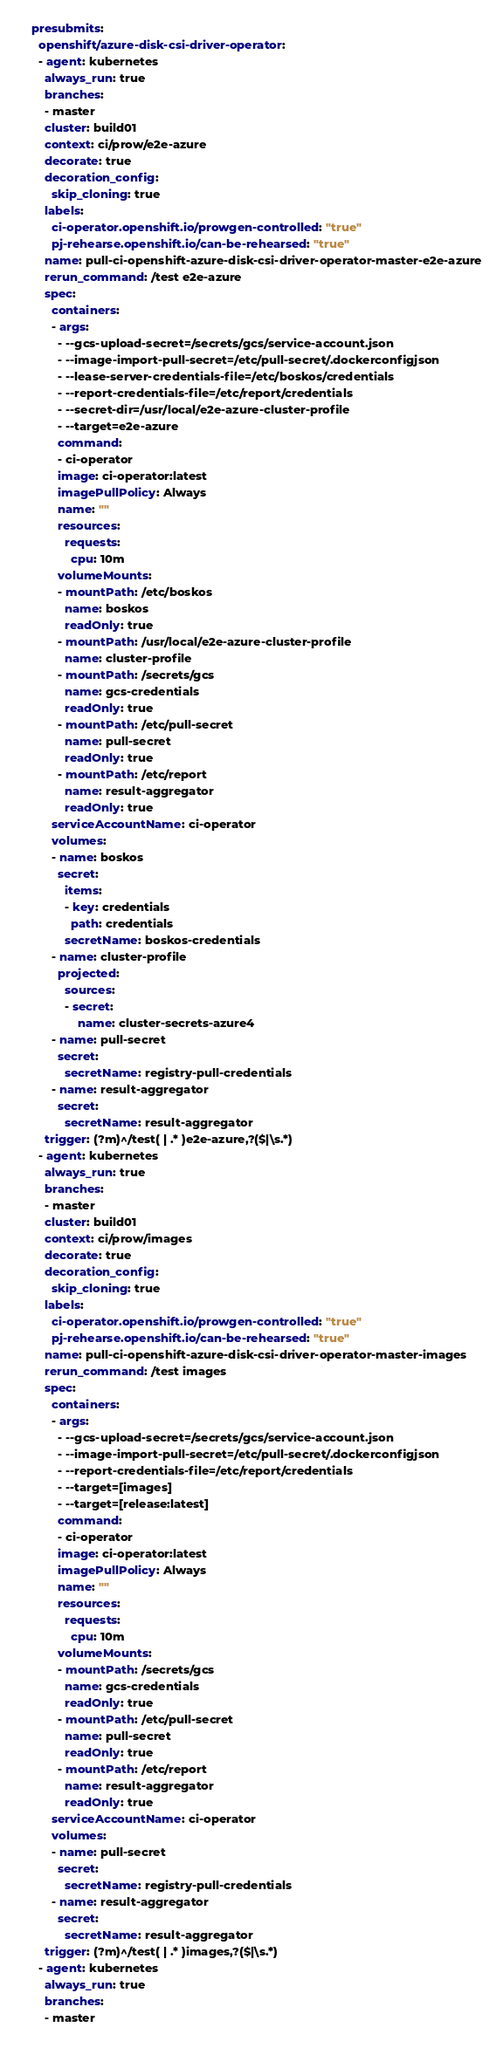<code> <loc_0><loc_0><loc_500><loc_500><_YAML_>presubmits:
  openshift/azure-disk-csi-driver-operator:
  - agent: kubernetes
    always_run: true
    branches:
    - master
    cluster: build01
    context: ci/prow/e2e-azure
    decorate: true
    decoration_config:
      skip_cloning: true
    labels:
      ci-operator.openshift.io/prowgen-controlled: "true"
      pj-rehearse.openshift.io/can-be-rehearsed: "true"
    name: pull-ci-openshift-azure-disk-csi-driver-operator-master-e2e-azure
    rerun_command: /test e2e-azure
    spec:
      containers:
      - args:
        - --gcs-upload-secret=/secrets/gcs/service-account.json
        - --image-import-pull-secret=/etc/pull-secret/.dockerconfigjson
        - --lease-server-credentials-file=/etc/boskos/credentials
        - --report-credentials-file=/etc/report/credentials
        - --secret-dir=/usr/local/e2e-azure-cluster-profile
        - --target=e2e-azure
        command:
        - ci-operator
        image: ci-operator:latest
        imagePullPolicy: Always
        name: ""
        resources:
          requests:
            cpu: 10m
        volumeMounts:
        - mountPath: /etc/boskos
          name: boskos
          readOnly: true
        - mountPath: /usr/local/e2e-azure-cluster-profile
          name: cluster-profile
        - mountPath: /secrets/gcs
          name: gcs-credentials
          readOnly: true
        - mountPath: /etc/pull-secret
          name: pull-secret
          readOnly: true
        - mountPath: /etc/report
          name: result-aggregator
          readOnly: true
      serviceAccountName: ci-operator
      volumes:
      - name: boskos
        secret:
          items:
          - key: credentials
            path: credentials
          secretName: boskos-credentials
      - name: cluster-profile
        projected:
          sources:
          - secret:
              name: cluster-secrets-azure4
      - name: pull-secret
        secret:
          secretName: registry-pull-credentials
      - name: result-aggregator
        secret:
          secretName: result-aggregator
    trigger: (?m)^/test( | .* )e2e-azure,?($|\s.*)
  - agent: kubernetes
    always_run: true
    branches:
    - master
    cluster: build01
    context: ci/prow/images
    decorate: true
    decoration_config:
      skip_cloning: true
    labels:
      ci-operator.openshift.io/prowgen-controlled: "true"
      pj-rehearse.openshift.io/can-be-rehearsed: "true"
    name: pull-ci-openshift-azure-disk-csi-driver-operator-master-images
    rerun_command: /test images
    spec:
      containers:
      - args:
        - --gcs-upload-secret=/secrets/gcs/service-account.json
        - --image-import-pull-secret=/etc/pull-secret/.dockerconfigjson
        - --report-credentials-file=/etc/report/credentials
        - --target=[images]
        - --target=[release:latest]
        command:
        - ci-operator
        image: ci-operator:latest
        imagePullPolicy: Always
        name: ""
        resources:
          requests:
            cpu: 10m
        volumeMounts:
        - mountPath: /secrets/gcs
          name: gcs-credentials
          readOnly: true
        - mountPath: /etc/pull-secret
          name: pull-secret
          readOnly: true
        - mountPath: /etc/report
          name: result-aggregator
          readOnly: true
      serviceAccountName: ci-operator
      volumes:
      - name: pull-secret
        secret:
          secretName: registry-pull-credentials
      - name: result-aggregator
        secret:
          secretName: result-aggregator
    trigger: (?m)^/test( | .* )images,?($|\s.*)
  - agent: kubernetes
    always_run: true
    branches:
    - master</code> 